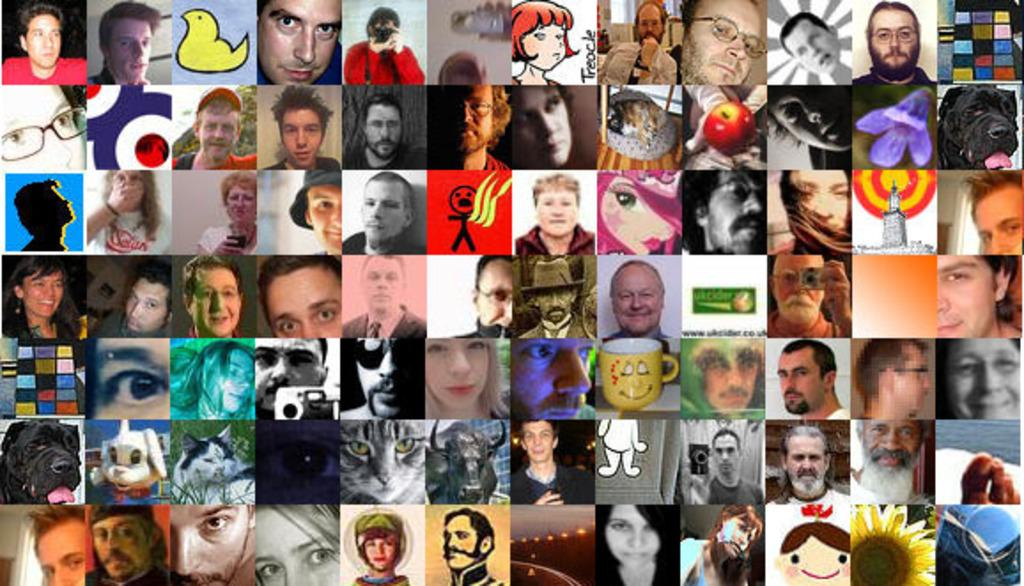What type of images are present in the collage in the image? The collage images contain faces of persons, images of animals, and images of flowers. Can you describe any other objects present in the collage images? Yes, there is a cup in the collage images. What role does the servant play in the collage images? There is no servant present in the collage images. How does friction affect the collage images? Friction is not a factor in the collage images, as they are a static representation of various images. 